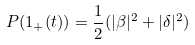Convert formula to latex. <formula><loc_0><loc_0><loc_500><loc_500>P ( 1 _ { + } ( t ) ) = \frac { 1 } { 2 } ( | \beta | ^ { 2 } + | \delta | ^ { 2 } )</formula> 